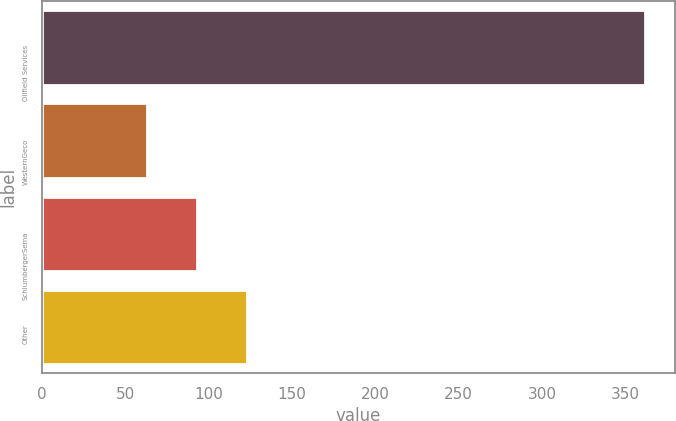Convert chart to OTSL. <chart><loc_0><loc_0><loc_500><loc_500><bar_chart><fcel>Oilfield Services<fcel>WesternGeco<fcel>SchlumbergerSema<fcel>Other<nl><fcel>362<fcel>63<fcel>92.9<fcel>122.8<nl></chart> 